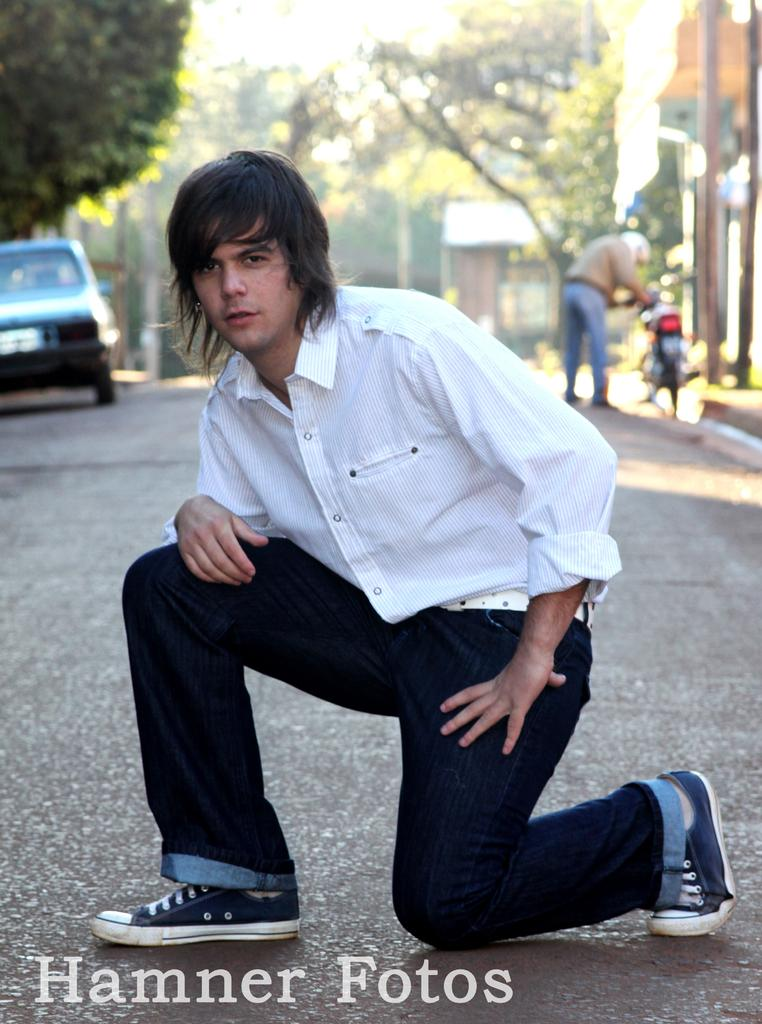What is the man in the image wearing? The man in the image is wearing a white shirt. What can be seen in the background of the image? In the background of the image, there is a motorcycle, a person, a car, houses, and trees. How many people are visible in the image? There is one man in the foreground and one person in the background, making a total of two people visible in the image. What type of game is the farmer playing in the image? There is no farmer or game present in the image. What story is being told by the people in the image? There is no story being told by the people in the image; it is a simple scene with a man in the foreground and a person in the background. 